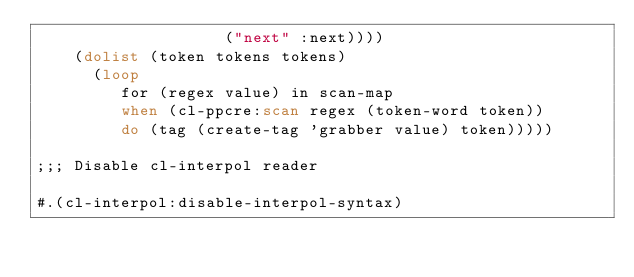<code> <loc_0><loc_0><loc_500><loc_500><_Lisp_>                    ("next" :next))))
    (dolist (token tokens tokens)
      (loop
         for (regex value) in scan-map
         when (cl-ppcre:scan regex (token-word token))
         do (tag (create-tag 'grabber value) token)))))

;;; Disable cl-interpol reader

#.(cl-interpol:disable-interpol-syntax)</code> 